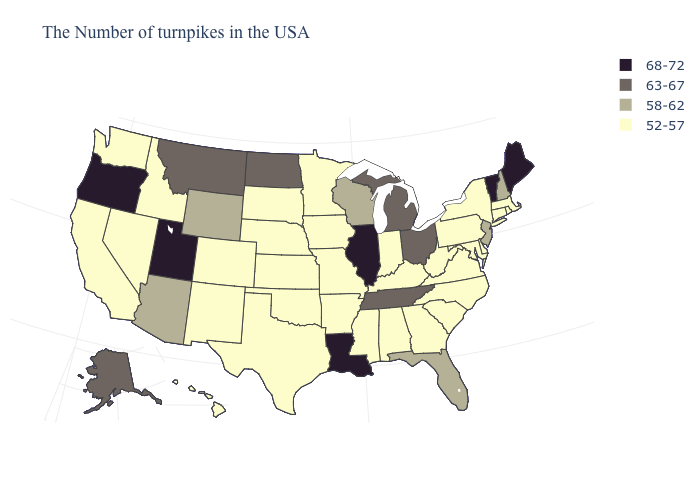Name the states that have a value in the range 68-72?
Short answer required. Maine, Vermont, Illinois, Louisiana, Utah, Oregon. What is the value of South Carolina?
Quick response, please. 52-57. Name the states that have a value in the range 63-67?
Be succinct. Ohio, Michigan, Tennessee, North Dakota, Montana, Alaska. What is the value of Ohio?
Keep it brief. 63-67. Is the legend a continuous bar?
Short answer required. No. Is the legend a continuous bar?
Concise answer only. No. Does the first symbol in the legend represent the smallest category?
Give a very brief answer. No. Name the states that have a value in the range 52-57?
Short answer required. Massachusetts, Rhode Island, Connecticut, New York, Delaware, Maryland, Pennsylvania, Virginia, North Carolina, South Carolina, West Virginia, Georgia, Kentucky, Indiana, Alabama, Mississippi, Missouri, Arkansas, Minnesota, Iowa, Kansas, Nebraska, Oklahoma, Texas, South Dakota, Colorado, New Mexico, Idaho, Nevada, California, Washington, Hawaii. What is the value of Colorado?
Keep it brief. 52-57. What is the highest value in the West ?
Be succinct. 68-72. Name the states that have a value in the range 68-72?
Keep it brief. Maine, Vermont, Illinois, Louisiana, Utah, Oregon. Name the states that have a value in the range 52-57?
Keep it brief. Massachusetts, Rhode Island, Connecticut, New York, Delaware, Maryland, Pennsylvania, Virginia, North Carolina, South Carolina, West Virginia, Georgia, Kentucky, Indiana, Alabama, Mississippi, Missouri, Arkansas, Minnesota, Iowa, Kansas, Nebraska, Oklahoma, Texas, South Dakota, Colorado, New Mexico, Idaho, Nevada, California, Washington, Hawaii. Does Kentucky have the same value as Maryland?
Keep it brief. Yes. Among the states that border Maryland , which have the highest value?
Quick response, please. Delaware, Pennsylvania, Virginia, West Virginia. What is the lowest value in the USA?
Quick response, please. 52-57. 